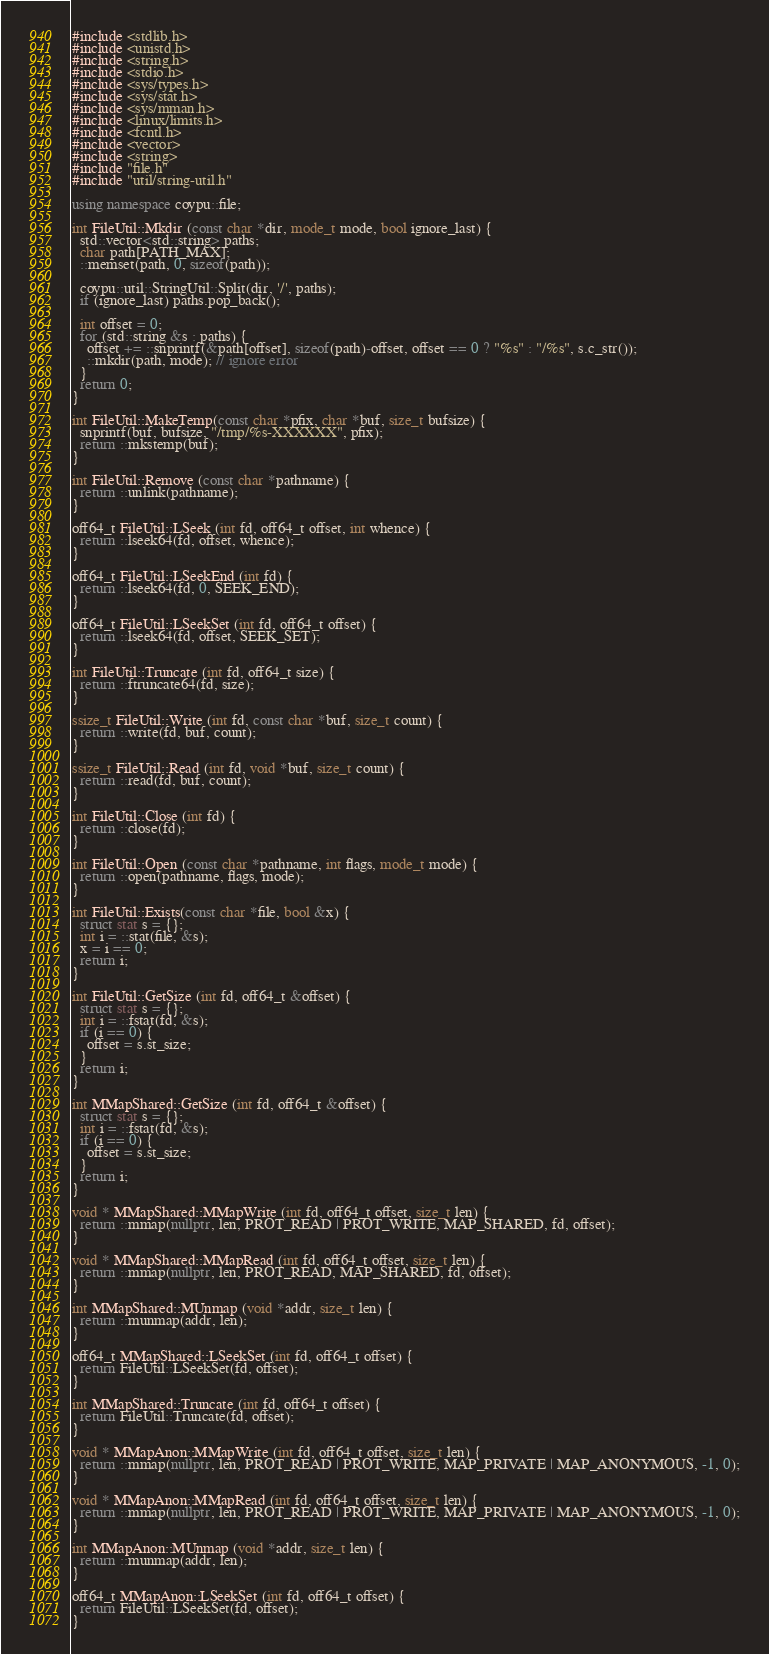Convert code to text. <code><loc_0><loc_0><loc_500><loc_500><_C++_>#include <stdlib.h>
#include <unistd.h>
#include <string.h>
#include <stdio.h>
#include <sys/types.h>
#include <sys/stat.h>
#include <sys/mman.h>
#include <linux/limits.h>
#include <fcntl.h>
#include <vector>
#include <string>
#include "file.h"
#include "util/string-util.h"

using namespace coypu::file;

int FileUtil::Mkdir (const char *dir, mode_t mode, bool ignore_last) {
  std::vector<std::string> paths;
  char path[PATH_MAX];
  ::memset(path, 0, sizeof(path));

  coypu::util::StringUtil::Split(dir, '/', paths);
  if (ignore_last) paths.pop_back();

  int offset = 0;
  for (std::string &s : paths) {
    offset += ::snprintf(&path[offset], sizeof(path)-offset, offset == 0 ? "%s" : "/%s", s.c_str());
    ::mkdir(path, mode); // ignore error
  }
  return 0;
}

int FileUtil::MakeTemp(const char *pfix, char *buf, size_t bufsize) {
  snprintf(buf, bufsize, "/tmp/%s-XXXXXX", pfix);
  return ::mkstemp(buf);
}

int FileUtil::Remove (const char *pathname) {
  return ::unlink(pathname);
}

off64_t FileUtil::LSeek (int fd, off64_t offset, int whence) {
  return ::lseek64(fd, offset, whence);
}

off64_t FileUtil::LSeekEnd (int fd) {
  return ::lseek64(fd, 0, SEEK_END);
}

off64_t FileUtil::LSeekSet (int fd, off64_t offset) {
  return ::lseek64(fd, offset, SEEK_SET);
}

int FileUtil::Truncate (int fd, off64_t size) {
  return ::ftruncate64(fd, size);
}

ssize_t FileUtil::Write (int fd, const char *buf, size_t count) {
  return ::write(fd, buf, count);
}

ssize_t FileUtil::Read (int fd, void *buf, size_t count) {
  return ::read(fd, buf, count);
}

int FileUtil::Close (int fd) {
  return ::close(fd);
}

int FileUtil::Open (const char *pathname, int flags, mode_t mode) {
  return ::open(pathname, flags, mode);
}

int FileUtil::Exists(const char *file, bool &x) {
  struct stat s = {};
  int i = ::stat(file, &s);
  x = i == 0;
  return i;
}

int FileUtil::GetSize (int fd, off64_t &offset) {
  struct stat s = {};
  int i = ::fstat(fd, &s);
  if (i == 0) {
    offset = s.st_size;
  }
  return i;
}

int MMapShared::GetSize (int fd, off64_t &offset) {
  struct stat s = {};
  int i = ::fstat(fd, &s);
  if (i == 0) {
    offset = s.st_size;
  }
  return i;
}
  
void * MMapShared::MMapWrite (int fd, off64_t offset, size_t len) {
  return ::mmap(nullptr, len, PROT_READ | PROT_WRITE, MAP_SHARED, fd, offset);
}

void * MMapShared::MMapRead (int fd, off64_t offset, size_t len) {
  return ::mmap(nullptr, len, PROT_READ, MAP_SHARED, fd, offset);
}

int MMapShared::MUnmap (void *addr, size_t len) {
  return ::munmap(addr, len);
}

off64_t MMapShared::LSeekSet (int fd, off64_t offset) {
  return FileUtil::LSeekSet(fd, offset);
}

int MMapShared::Truncate (int fd, off64_t offset) {
  return FileUtil::Truncate(fd, offset);
}

void * MMapAnon::MMapWrite (int fd, off64_t offset, size_t len) {
  return ::mmap(nullptr, len, PROT_READ | PROT_WRITE, MAP_PRIVATE | MAP_ANONYMOUS, -1, 0);
}

void * MMapAnon::MMapRead (int fd, off64_t offset, size_t len) {
  return ::mmap(nullptr, len, PROT_READ | PROT_WRITE, MAP_PRIVATE | MAP_ANONYMOUS, -1, 0);
}

int MMapAnon::MUnmap (void *addr, size_t len) {
  return ::munmap(addr, len);
}

off64_t MMapAnon::LSeekSet (int fd, off64_t offset) {
  return FileUtil::LSeekSet(fd, offset);
}
</code> 